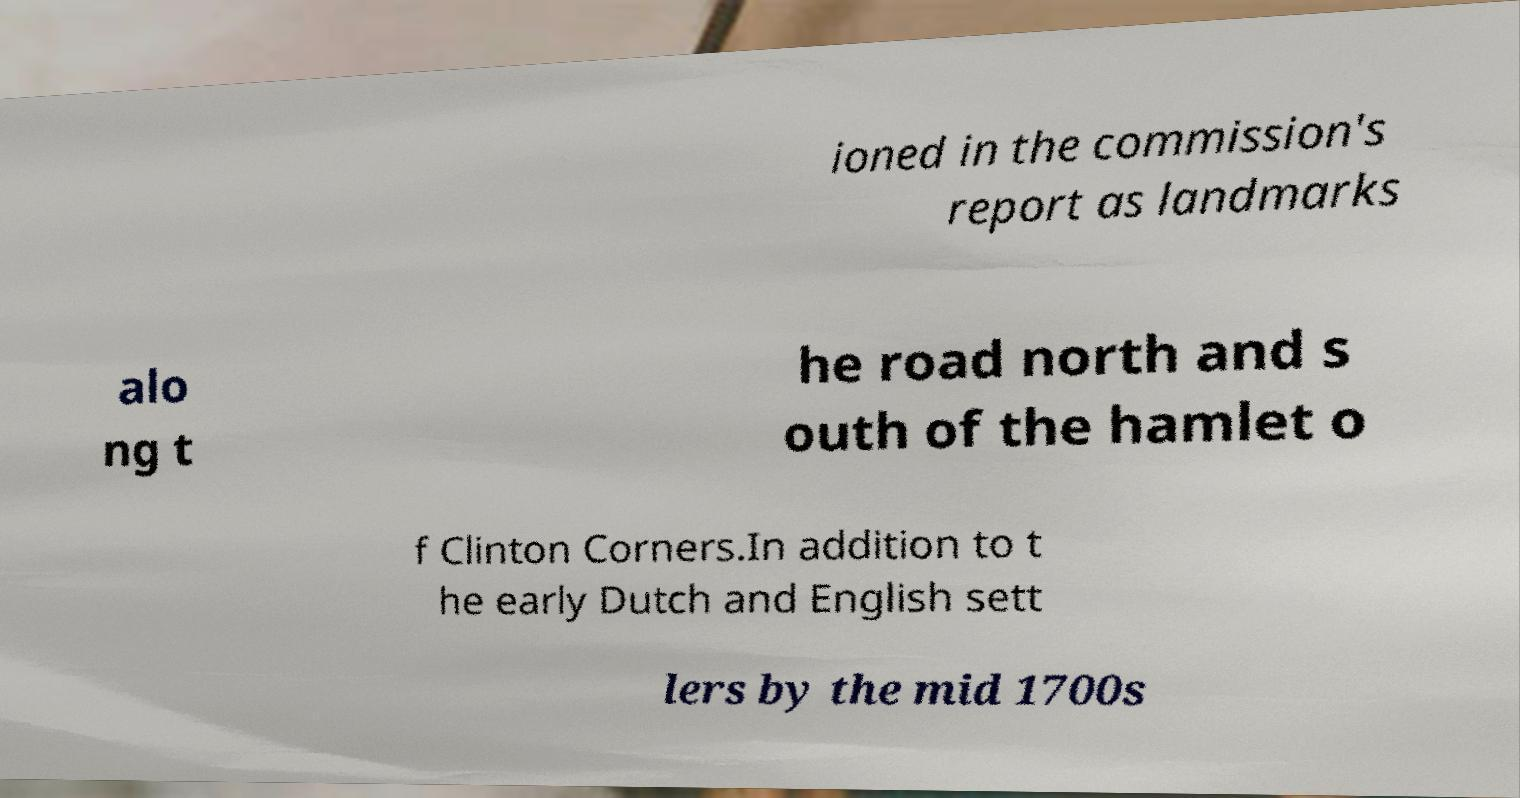Please read and relay the text visible in this image. What does it say? ioned in the commission's report as landmarks alo ng t he road north and s outh of the hamlet o f Clinton Corners.In addition to t he early Dutch and English sett lers by the mid 1700s 